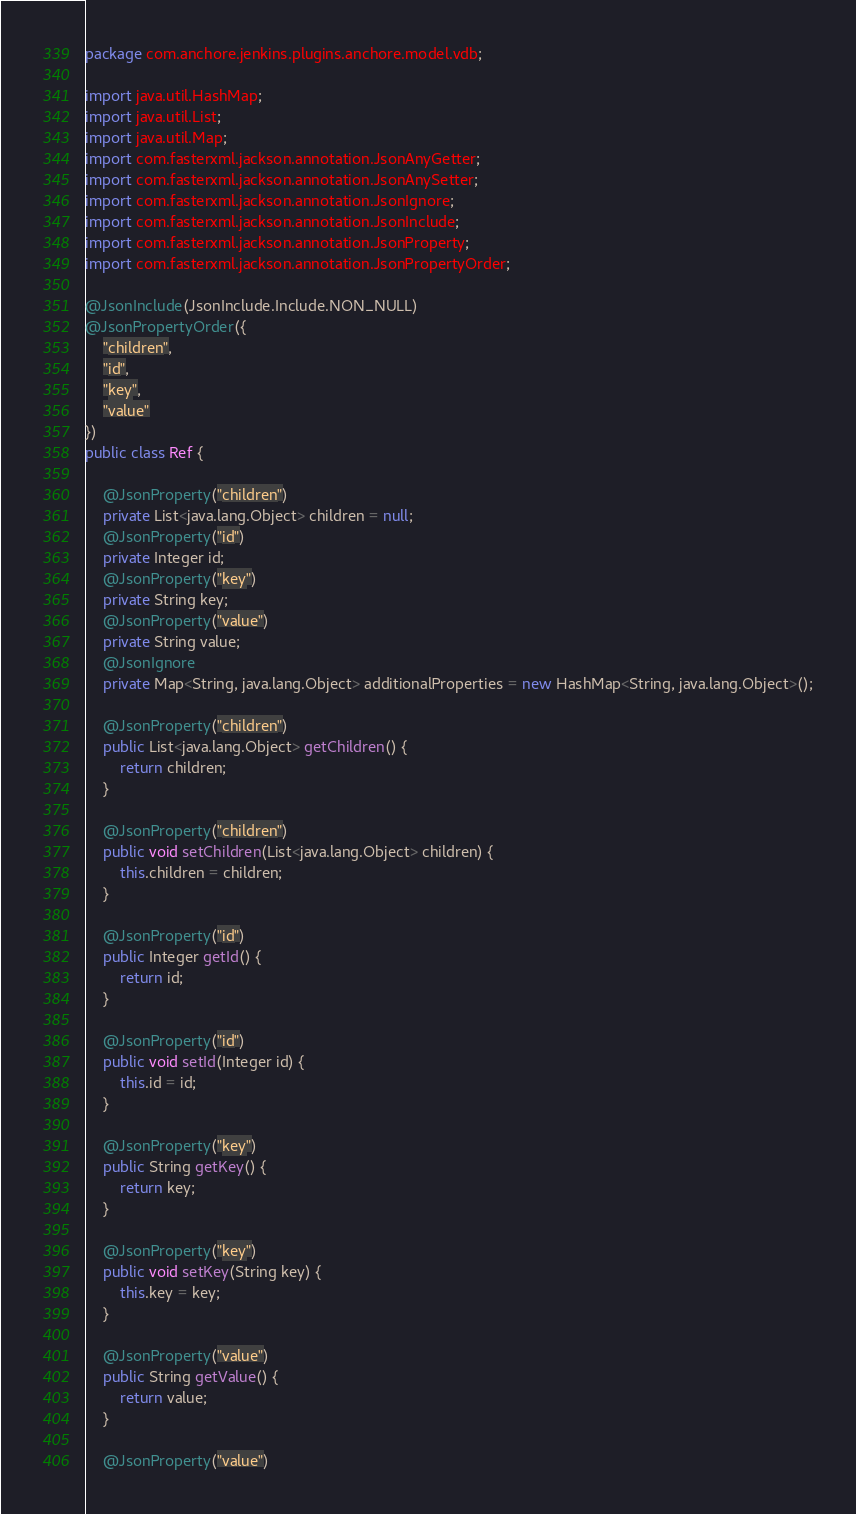<code> <loc_0><loc_0><loc_500><loc_500><_Java_>package com.anchore.jenkins.plugins.anchore.model.vdb;

import java.util.HashMap;
import java.util.List;
import java.util.Map;
import com.fasterxml.jackson.annotation.JsonAnyGetter;
import com.fasterxml.jackson.annotation.JsonAnySetter;
import com.fasterxml.jackson.annotation.JsonIgnore;
import com.fasterxml.jackson.annotation.JsonInclude;
import com.fasterxml.jackson.annotation.JsonProperty;
import com.fasterxml.jackson.annotation.JsonPropertyOrder;

@JsonInclude(JsonInclude.Include.NON_NULL)
@JsonPropertyOrder({
    "children",
    "id",
    "key",
    "value"
})
public class Ref {

    @JsonProperty("children")
    private List<java.lang.Object> children = null;
    @JsonProperty("id")
    private Integer id;
    @JsonProperty("key")
    private String key;
    @JsonProperty("value")
    private String value;
    @JsonIgnore
    private Map<String, java.lang.Object> additionalProperties = new HashMap<String, java.lang.Object>();

    @JsonProperty("children")
    public List<java.lang.Object> getChildren() {
        return children;
    }

    @JsonProperty("children")
    public void setChildren(List<java.lang.Object> children) {
        this.children = children;
    }

    @JsonProperty("id")
    public Integer getId() {
        return id;
    }

    @JsonProperty("id")
    public void setId(Integer id) {
        this.id = id;
    }

    @JsonProperty("key")
    public String getKey() {
        return key;
    }

    @JsonProperty("key")
    public void setKey(String key) {
        this.key = key;
    }

    @JsonProperty("value")
    public String getValue() {
        return value;
    }

    @JsonProperty("value")</code> 